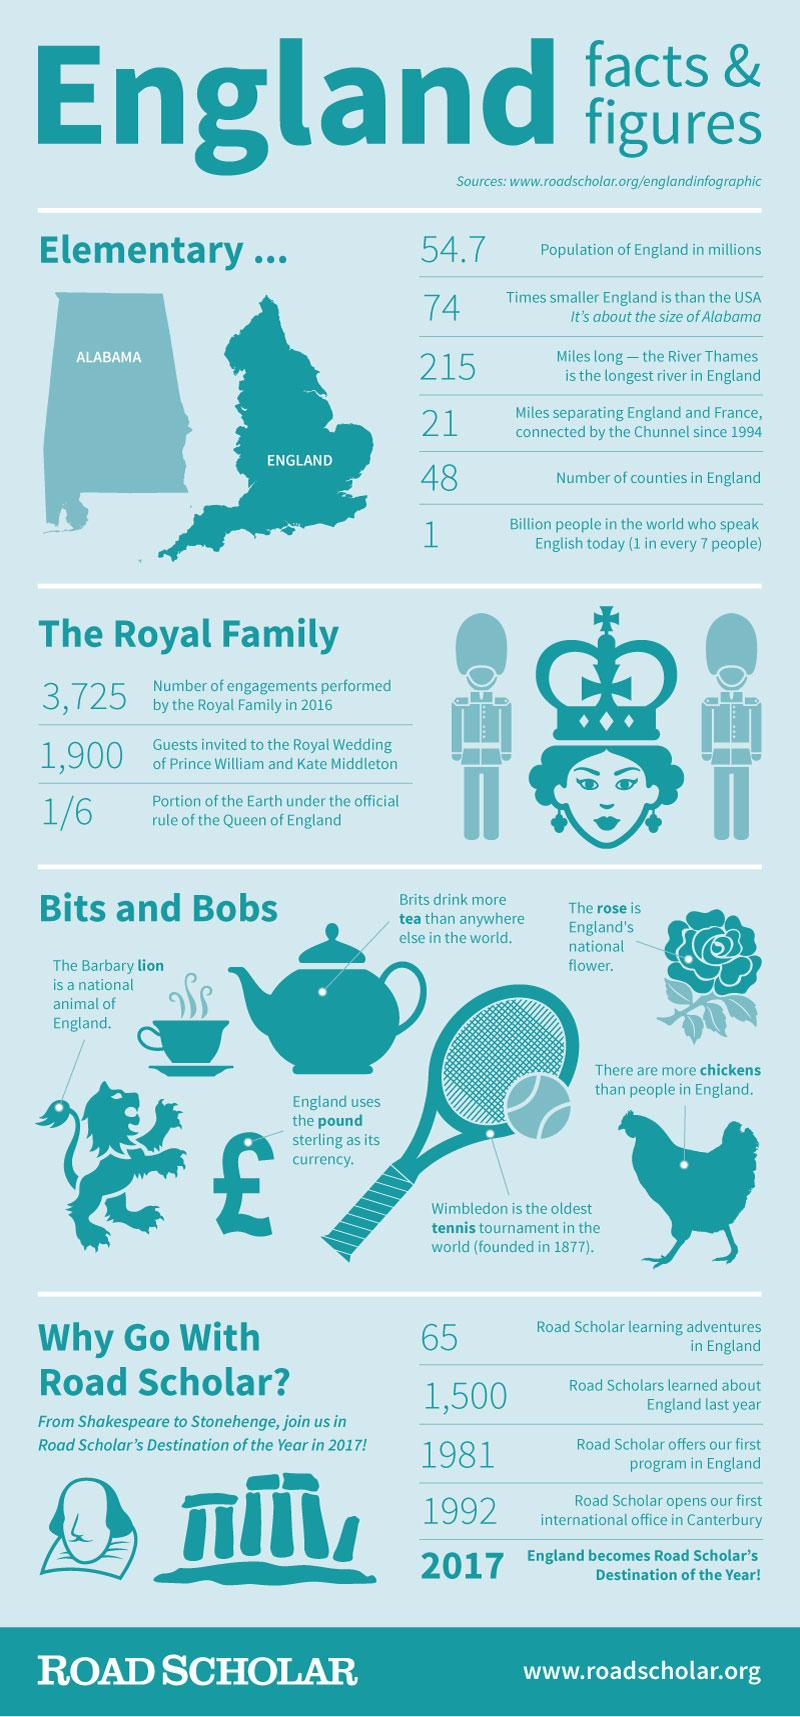Identify some key points in this picture. The size of England is compared to that of the US state of Alabama. The national flower of England is the rose. The population of England is approximately 54.7 million. The oldest tennis tournament in the world is Wimbledon. Approximately 1/6 of the Earth's land mass is under the official rule of the Queen of England. 